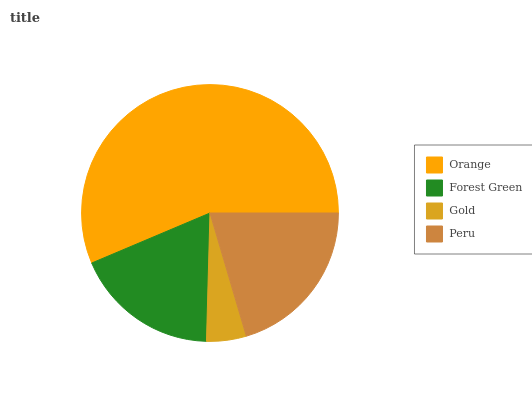Is Gold the minimum?
Answer yes or no. Yes. Is Orange the maximum?
Answer yes or no. Yes. Is Forest Green the minimum?
Answer yes or no. No. Is Forest Green the maximum?
Answer yes or no. No. Is Orange greater than Forest Green?
Answer yes or no. Yes. Is Forest Green less than Orange?
Answer yes or no. Yes. Is Forest Green greater than Orange?
Answer yes or no. No. Is Orange less than Forest Green?
Answer yes or no. No. Is Peru the high median?
Answer yes or no. Yes. Is Forest Green the low median?
Answer yes or no. Yes. Is Forest Green the high median?
Answer yes or no. No. Is Peru the low median?
Answer yes or no. No. 